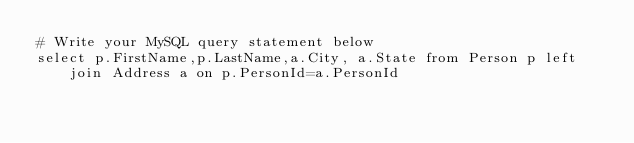Convert code to text. <code><loc_0><loc_0><loc_500><loc_500><_SQL_># Write your MySQL query statement below
select p.FirstName,p.LastName,a.City, a.State from Person p left join Address a on p.PersonId=a.PersonId
</code> 